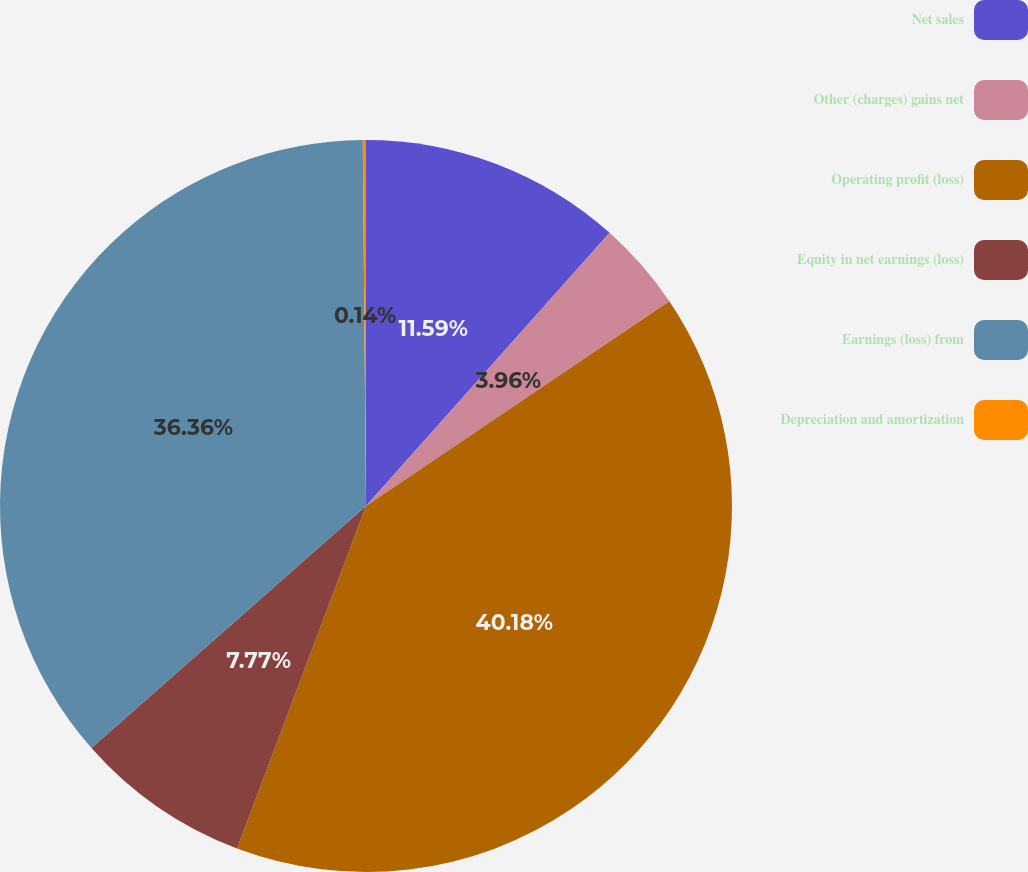Convert chart. <chart><loc_0><loc_0><loc_500><loc_500><pie_chart><fcel>Net sales<fcel>Other (charges) gains net<fcel>Operating profit (loss)<fcel>Equity in net earnings (loss)<fcel>Earnings (loss) from<fcel>Depreciation and amortization<nl><fcel>11.59%<fcel>3.96%<fcel>40.18%<fcel>7.77%<fcel>36.36%<fcel>0.14%<nl></chart> 